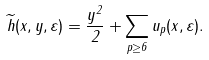Convert formula to latex. <formula><loc_0><loc_0><loc_500><loc_500>\widetilde { h } ( x , y , \varepsilon ) = \frac { y ^ { 2 } } { 2 } + \sum _ { p \geq 6 } u _ { p } ( x , \varepsilon ) .</formula> 